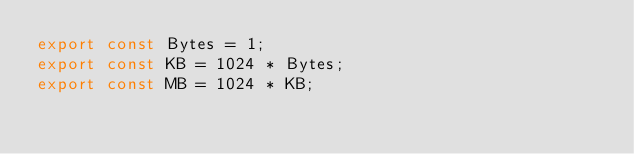<code> <loc_0><loc_0><loc_500><loc_500><_JavaScript_>export const Bytes = 1;
export const KB = 1024 * Bytes;
export const MB = 1024 * KB;</code> 